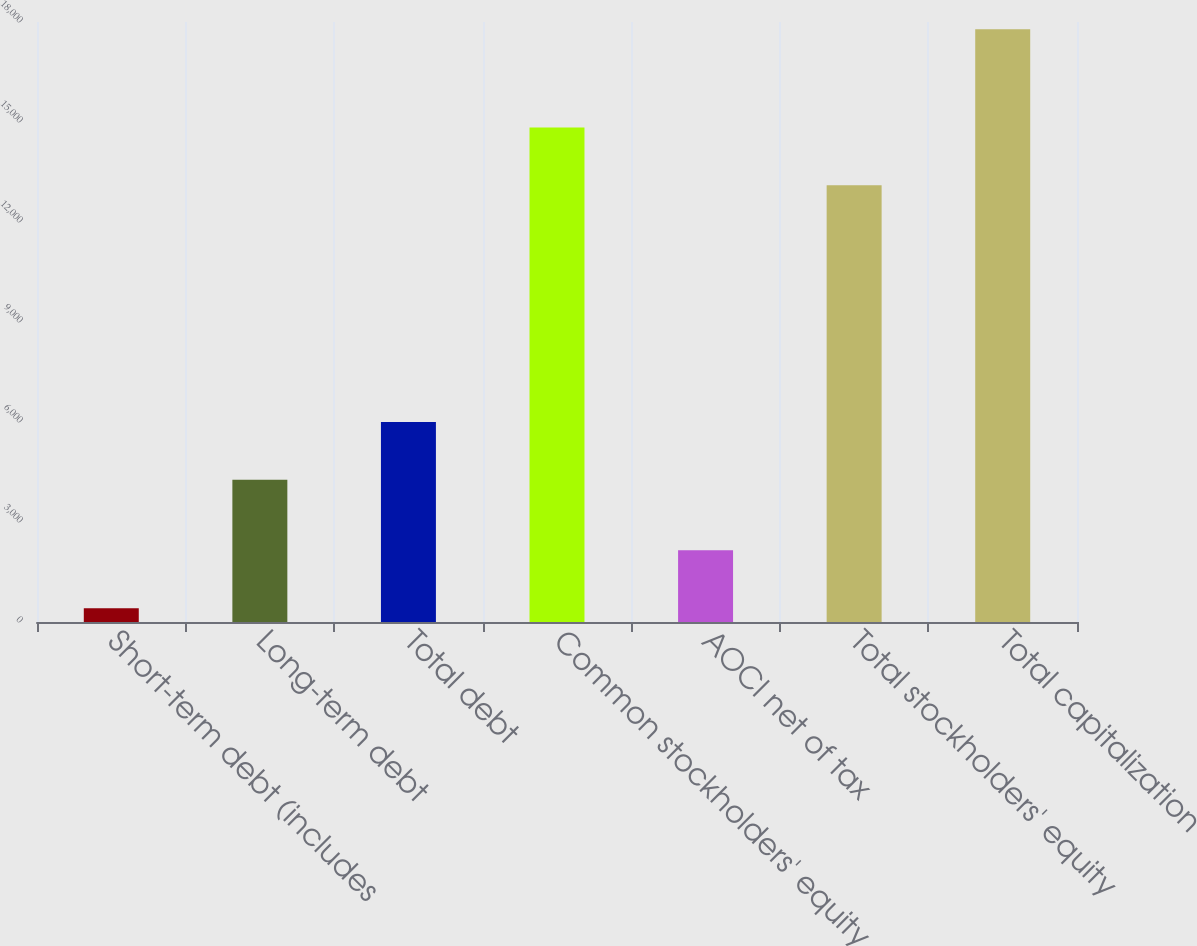Convert chart to OTSL. <chart><loc_0><loc_0><loc_500><loc_500><bar_chart><fcel>Short-term debt (includes<fcel>Long-term debt<fcel>Total debt<fcel>Common stockholders' equity<fcel>AOCI net of tax<fcel>Total stockholders' equity<fcel>Total capitalization<nl><fcel>413<fcel>4265<fcel>6001.6<fcel>14837.6<fcel>2149.6<fcel>13101<fcel>17779<nl></chart> 